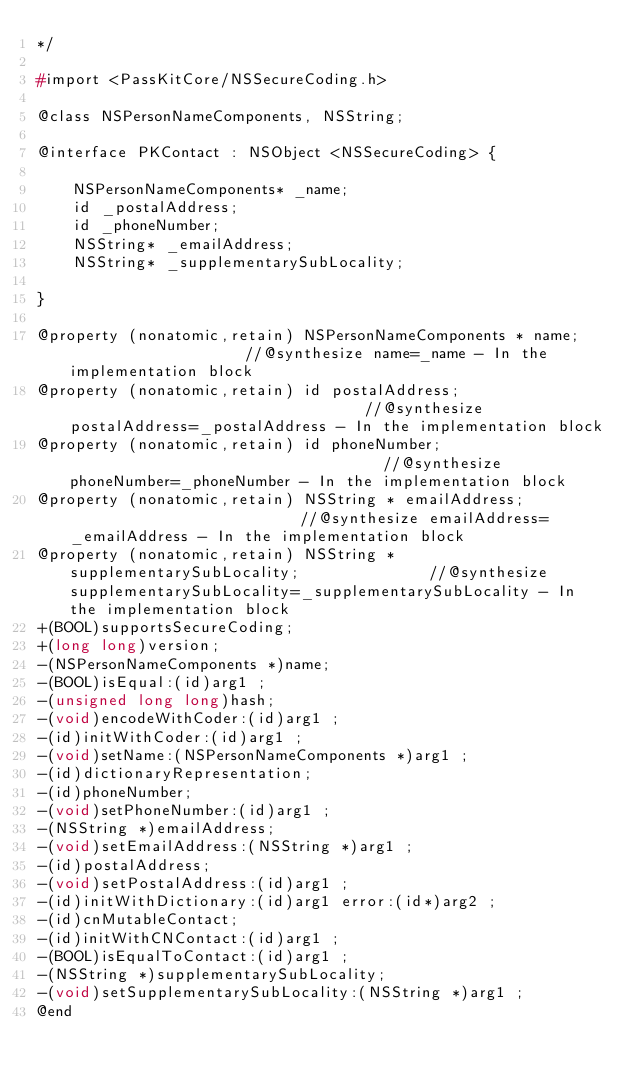Convert code to text. <code><loc_0><loc_0><loc_500><loc_500><_C_>*/

#import <PassKitCore/NSSecureCoding.h>

@class NSPersonNameComponents, NSString;

@interface PKContact : NSObject <NSSecureCoding> {

	NSPersonNameComponents* _name;
	id _postalAddress;
	id _phoneNumber;
	NSString* _emailAddress;
	NSString* _supplementarySubLocality;

}

@property (nonatomic,retain) NSPersonNameComponents * name;                    //@synthesize name=_name - In the implementation block
@property (nonatomic,retain) id postalAddress;                                 //@synthesize postalAddress=_postalAddress - In the implementation block
@property (nonatomic,retain) id phoneNumber;                                   //@synthesize phoneNumber=_phoneNumber - In the implementation block
@property (nonatomic,retain) NSString * emailAddress;                          //@synthesize emailAddress=_emailAddress - In the implementation block
@property (nonatomic,retain) NSString * supplementarySubLocality;              //@synthesize supplementarySubLocality=_supplementarySubLocality - In the implementation block
+(BOOL)supportsSecureCoding;
+(long long)version;
-(NSPersonNameComponents *)name;
-(BOOL)isEqual:(id)arg1 ;
-(unsigned long long)hash;
-(void)encodeWithCoder:(id)arg1 ;
-(id)initWithCoder:(id)arg1 ;
-(void)setName:(NSPersonNameComponents *)arg1 ;
-(id)dictionaryRepresentation;
-(id)phoneNumber;
-(void)setPhoneNumber:(id)arg1 ;
-(NSString *)emailAddress;
-(void)setEmailAddress:(NSString *)arg1 ;
-(id)postalAddress;
-(void)setPostalAddress:(id)arg1 ;
-(id)initWithDictionary:(id)arg1 error:(id*)arg2 ;
-(id)cnMutableContact;
-(id)initWithCNContact:(id)arg1 ;
-(BOOL)isEqualToContact:(id)arg1 ;
-(NSString *)supplementarySubLocality;
-(void)setSupplementarySubLocality:(NSString *)arg1 ;
@end

</code> 